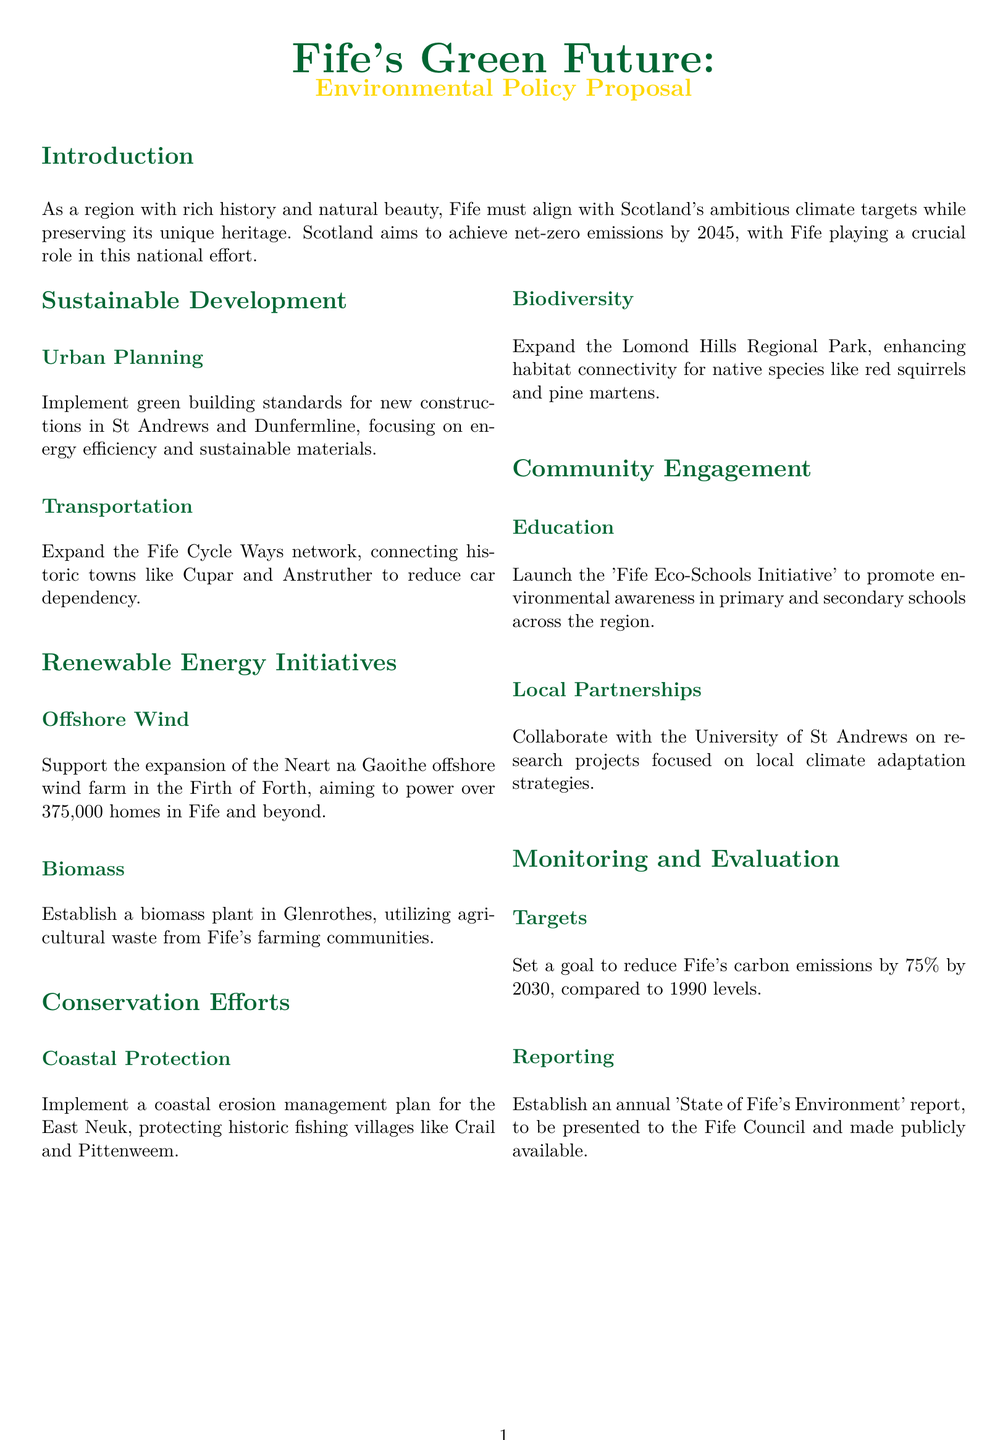What is Fife's target year for net-zero emissions? The target year for net-zero emissions for Scotland is 2045, which Fife must align with.
Answer: 2045 What are the two main renewable energy initiatives mentioned? The two main renewable energy initiatives mentioned in the document are offshore wind and biomass.
Answer: Offshore Wind, Biomass What percentage reduction in carbon emissions is Fife aiming for by 2030? The document states that Fife aims to reduce its carbon emissions by 75% by 2030 compared to 1990 levels.
Answer: 75% Which historic town is included in the expansion of the Fife Cycle Ways network? The town of Anstruther is mentioned as being connected through the expanded Fife Cycle Ways network.
Answer: Anstruther What is the proposed biomass plant's location? The document specifies that the biomass plant will be established in Glenrothes.
Answer: Glenrothes What is the name of the educational initiative to promote environmental awareness? The educational initiative mentioned for promoting environmental awareness is the 'Fife Eco-Schools Initiative'.
Answer: Fife Eco-Schools Initiative What annual report is to be established regarding Fife's environment? The document states that an annual 'State of Fife's Environment' report will be established.
Answer: State of Fife's Environment Which unique feature of Fife's environment is mentioned for conservation efforts? The coastal erosion management plan for the East Neuk is specifically mentioned as a unique feature for conservation efforts.
Answer: Coastal erosion management plan 